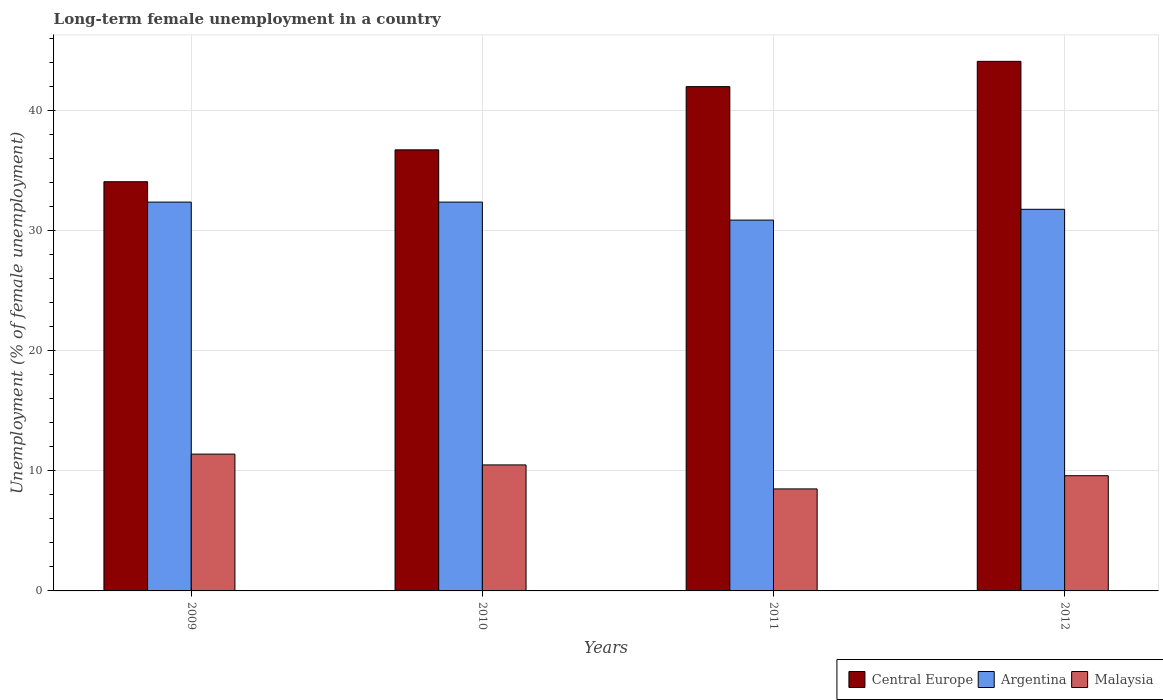How many different coloured bars are there?
Your answer should be compact. 3. How many bars are there on the 1st tick from the right?
Ensure brevity in your answer.  3. What is the label of the 4th group of bars from the left?
Give a very brief answer. 2012. In how many cases, is the number of bars for a given year not equal to the number of legend labels?
Provide a succinct answer. 0. What is the percentage of long-term unemployed female population in Central Europe in 2012?
Your answer should be very brief. 44.13. Across all years, what is the maximum percentage of long-term unemployed female population in Central Europe?
Your answer should be very brief. 44.13. Across all years, what is the minimum percentage of long-term unemployed female population in Central Europe?
Ensure brevity in your answer.  34.1. In which year was the percentage of long-term unemployed female population in Central Europe maximum?
Provide a succinct answer. 2012. What is the total percentage of long-term unemployed female population in Malaysia in the graph?
Make the answer very short. 40. What is the difference between the percentage of long-term unemployed female population in Argentina in 2010 and that in 2012?
Provide a short and direct response. 0.6. What is the difference between the percentage of long-term unemployed female population in Central Europe in 2011 and the percentage of long-term unemployed female population in Malaysia in 2009?
Provide a succinct answer. 30.62. What is the average percentage of long-term unemployed female population in Central Europe per year?
Your answer should be compact. 39.25. In the year 2009, what is the difference between the percentage of long-term unemployed female population in Central Europe and percentage of long-term unemployed female population in Argentina?
Your response must be concise. 1.7. What is the ratio of the percentage of long-term unemployed female population in Argentina in 2011 to that in 2012?
Your response must be concise. 0.97. What is the difference between the highest and the second highest percentage of long-term unemployed female population in Malaysia?
Ensure brevity in your answer.  0.9. What is the difference between the highest and the lowest percentage of long-term unemployed female population in Central Europe?
Provide a succinct answer. 10.03. Is the sum of the percentage of long-term unemployed female population in Argentina in 2009 and 2010 greater than the maximum percentage of long-term unemployed female population in Central Europe across all years?
Make the answer very short. Yes. What does the 3rd bar from the left in 2012 represents?
Offer a very short reply. Malaysia. What does the 3rd bar from the right in 2011 represents?
Offer a very short reply. Central Europe. Are all the bars in the graph horizontal?
Give a very brief answer. No. Does the graph contain any zero values?
Your response must be concise. No. Does the graph contain grids?
Keep it short and to the point. Yes. How are the legend labels stacked?
Keep it short and to the point. Horizontal. What is the title of the graph?
Provide a short and direct response. Long-term female unemployment in a country. What is the label or title of the Y-axis?
Keep it short and to the point. Unemployment (% of female unemployment). What is the Unemployment (% of female unemployment) in Central Europe in 2009?
Keep it short and to the point. 34.1. What is the Unemployment (% of female unemployment) in Argentina in 2009?
Your response must be concise. 32.4. What is the Unemployment (% of female unemployment) of Malaysia in 2009?
Provide a succinct answer. 11.4. What is the Unemployment (% of female unemployment) of Central Europe in 2010?
Your response must be concise. 36.75. What is the Unemployment (% of female unemployment) of Argentina in 2010?
Give a very brief answer. 32.4. What is the Unemployment (% of female unemployment) in Central Europe in 2011?
Your answer should be compact. 42.02. What is the Unemployment (% of female unemployment) of Argentina in 2011?
Ensure brevity in your answer.  30.9. What is the Unemployment (% of female unemployment) of Malaysia in 2011?
Make the answer very short. 8.5. What is the Unemployment (% of female unemployment) in Central Europe in 2012?
Ensure brevity in your answer.  44.13. What is the Unemployment (% of female unemployment) of Argentina in 2012?
Your answer should be very brief. 31.8. What is the Unemployment (% of female unemployment) in Malaysia in 2012?
Give a very brief answer. 9.6. Across all years, what is the maximum Unemployment (% of female unemployment) of Central Europe?
Keep it short and to the point. 44.13. Across all years, what is the maximum Unemployment (% of female unemployment) in Argentina?
Your response must be concise. 32.4. Across all years, what is the maximum Unemployment (% of female unemployment) in Malaysia?
Offer a very short reply. 11.4. Across all years, what is the minimum Unemployment (% of female unemployment) of Central Europe?
Ensure brevity in your answer.  34.1. Across all years, what is the minimum Unemployment (% of female unemployment) of Argentina?
Provide a succinct answer. 30.9. Across all years, what is the minimum Unemployment (% of female unemployment) of Malaysia?
Offer a very short reply. 8.5. What is the total Unemployment (% of female unemployment) in Central Europe in the graph?
Make the answer very short. 157. What is the total Unemployment (% of female unemployment) in Argentina in the graph?
Your response must be concise. 127.5. What is the difference between the Unemployment (% of female unemployment) of Central Europe in 2009 and that in 2010?
Ensure brevity in your answer.  -2.66. What is the difference between the Unemployment (% of female unemployment) in Argentina in 2009 and that in 2010?
Provide a short and direct response. 0. What is the difference between the Unemployment (% of female unemployment) of Central Europe in 2009 and that in 2011?
Provide a succinct answer. -7.93. What is the difference between the Unemployment (% of female unemployment) of Argentina in 2009 and that in 2011?
Keep it short and to the point. 1.5. What is the difference between the Unemployment (% of female unemployment) of Central Europe in 2009 and that in 2012?
Ensure brevity in your answer.  -10.03. What is the difference between the Unemployment (% of female unemployment) of Central Europe in 2010 and that in 2011?
Offer a very short reply. -5.27. What is the difference between the Unemployment (% of female unemployment) in Argentina in 2010 and that in 2011?
Your response must be concise. 1.5. What is the difference between the Unemployment (% of female unemployment) in Central Europe in 2010 and that in 2012?
Ensure brevity in your answer.  -7.37. What is the difference between the Unemployment (% of female unemployment) in Argentina in 2010 and that in 2012?
Give a very brief answer. 0.6. What is the difference between the Unemployment (% of female unemployment) in Malaysia in 2010 and that in 2012?
Keep it short and to the point. 0.9. What is the difference between the Unemployment (% of female unemployment) in Central Europe in 2011 and that in 2012?
Ensure brevity in your answer.  -2.1. What is the difference between the Unemployment (% of female unemployment) of Malaysia in 2011 and that in 2012?
Ensure brevity in your answer.  -1.1. What is the difference between the Unemployment (% of female unemployment) in Central Europe in 2009 and the Unemployment (% of female unemployment) in Argentina in 2010?
Ensure brevity in your answer.  1.7. What is the difference between the Unemployment (% of female unemployment) in Central Europe in 2009 and the Unemployment (% of female unemployment) in Malaysia in 2010?
Keep it short and to the point. 23.6. What is the difference between the Unemployment (% of female unemployment) of Argentina in 2009 and the Unemployment (% of female unemployment) of Malaysia in 2010?
Keep it short and to the point. 21.9. What is the difference between the Unemployment (% of female unemployment) in Central Europe in 2009 and the Unemployment (% of female unemployment) in Argentina in 2011?
Offer a terse response. 3.2. What is the difference between the Unemployment (% of female unemployment) in Central Europe in 2009 and the Unemployment (% of female unemployment) in Malaysia in 2011?
Your answer should be very brief. 25.6. What is the difference between the Unemployment (% of female unemployment) in Argentina in 2009 and the Unemployment (% of female unemployment) in Malaysia in 2011?
Make the answer very short. 23.9. What is the difference between the Unemployment (% of female unemployment) of Central Europe in 2009 and the Unemployment (% of female unemployment) of Argentina in 2012?
Provide a succinct answer. 2.3. What is the difference between the Unemployment (% of female unemployment) of Central Europe in 2009 and the Unemployment (% of female unemployment) of Malaysia in 2012?
Your answer should be very brief. 24.5. What is the difference between the Unemployment (% of female unemployment) in Argentina in 2009 and the Unemployment (% of female unemployment) in Malaysia in 2012?
Offer a terse response. 22.8. What is the difference between the Unemployment (% of female unemployment) of Central Europe in 2010 and the Unemployment (% of female unemployment) of Argentina in 2011?
Provide a short and direct response. 5.85. What is the difference between the Unemployment (% of female unemployment) of Central Europe in 2010 and the Unemployment (% of female unemployment) of Malaysia in 2011?
Your answer should be compact. 28.25. What is the difference between the Unemployment (% of female unemployment) in Argentina in 2010 and the Unemployment (% of female unemployment) in Malaysia in 2011?
Your answer should be very brief. 23.9. What is the difference between the Unemployment (% of female unemployment) in Central Europe in 2010 and the Unemployment (% of female unemployment) in Argentina in 2012?
Offer a very short reply. 4.95. What is the difference between the Unemployment (% of female unemployment) in Central Europe in 2010 and the Unemployment (% of female unemployment) in Malaysia in 2012?
Your response must be concise. 27.15. What is the difference between the Unemployment (% of female unemployment) in Argentina in 2010 and the Unemployment (% of female unemployment) in Malaysia in 2012?
Provide a succinct answer. 22.8. What is the difference between the Unemployment (% of female unemployment) of Central Europe in 2011 and the Unemployment (% of female unemployment) of Argentina in 2012?
Give a very brief answer. 10.22. What is the difference between the Unemployment (% of female unemployment) of Central Europe in 2011 and the Unemployment (% of female unemployment) of Malaysia in 2012?
Your response must be concise. 32.42. What is the difference between the Unemployment (% of female unemployment) of Argentina in 2011 and the Unemployment (% of female unemployment) of Malaysia in 2012?
Offer a terse response. 21.3. What is the average Unemployment (% of female unemployment) of Central Europe per year?
Your response must be concise. 39.25. What is the average Unemployment (% of female unemployment) in Argentina per year?
Give a very brief answer. 31.88. What is the average Unemployment (% of female unemployment) of Malaysia per year?
Provide a short and direct response. 10. In the year 2009, what is the difference between the Unemployment (% of female unemployment) in Central Europe and Unemployment (% of female unemployment) in Argentina?
Your answer should be compact. 1.7. In the year 2009, what is the difference between the Unemployment (% of female unemployment) of Central Europe and Unemployment (% of female unemployment) of Malaysia?
Offer a terse response. 22.7. In the year 2010, what is the difference between the Unemployment (% of female unemployment) in Central Europe and Unemployment (% of female unemployment) in Argentina?
Keep it short and to the point. 4.35. In the year 2010, what is the difference between the Unemployment (% of female unemployment) in Central Europe and Unemployment (% of female unemployment) in Malaysia?
Provide a short and direct response. 26.25. In the year 2010, what is the difference between the Unemployment (% of female unemployment) of Argentina and Unemployment (% of female unemployment) of Malaysia?
Offer a terse response. 21.9. In the year 2011, what is the difference between the Unemployment (% of female unemployment) in Central Europe and Unemployment (% of female unemployment) in Argentina?
Provide a succinct answer. 11.12. In the year 2011, what is the difference between the Unemployment (% of female unemployment) of Central Europe and Unemployment (% of female unemployment) of Malaysia?
Your response must be concise. 33.52. In the year 2011, what is the difference between the Unemployment (% of female unemployment) in Argentina and Unemployment (% of female unemployment) in Malaysia?
Give a very brief answer. 22.4. In the year 2012, what is the difference between the Unemployment (% of female unemployment) in Central Europe and Unemployment (% of female unemployment) in Argentina?
Ensure brevity in your answer.  12.33. In the year 2012, what is the difference between the Unemployment (% of female unemployment) of Central Europe and Unemployment (% of female unemployment) of Malaysia?
Offer a terse response. 34.53. In the year 2012, what is the difference between the Unemployment (% of female unemployment) of Argentina and Unemployment (% of female unemployment) of Malaysia?
Provide a short and direct response. 22.2. What is the ratio of the Unemployment (% of female unemployment) of Central Europe in 2009 to that in 2010?
Your response must be concise. 0.93. What is the ratio of the Unemployment (% of female unemployment) of Argentina in 2009 to that in 2010?
Your response must be concise. 1. What is the ratio of the Unemployment (% of female unemployment) of Malaysia in 2009 to that in 2010?
Keep it short and to the point. 1.09. What is the ratio of the Unemployment (% of female unemployment) of Central Europe in 2009 to that in 2011?
Your response must be concise. 0.81. What is the ratio of the Unemployment (% of female unemployment) in Argentina in 2009 to that in 2011?
Give a very brief answer. 1.05. What is the ratio of the Unemployment (% of female unemployment) of Malaysia in 2009 to that in 2011?
Provide a short and direct response. 1.34. What is the ratio of the Unemployment (% of female unemployment) of Central Europe in 2009 to that in 2012?
Provide a succinct answer. 0.77. What is the ratio of the Unemployment (% of female unemployment) of Argentina in 2009 to that in 2012?
Provide a short and direct response. 1.02. What is the ratio of the Unemployment (% of female unemployment) of Malaysia in 2009 to that in 2012?
Offer a terse response. 1.19. What is the ratio of the Unemployment (% of female unemployment) in Central Europe in 2010 to that in 2011?
Make the answer very short. 0.87. What is the ratio of the Unemployment (% of female unemployment) of Argentina in 2010 to that in 2011?
Give a very brief answer. 1.05. What is the ratio of the Unemployment (% of female unemployment) of Malaysia in 2010 to that in 2011?
Provide a succinct answer. 1.24. What is the ratio of the Unemployment (% of female unemployment) in Central Europe in 2010 to that in 2012?
Offer a very short reply. 0.83. What is the ratio of the Unemployment (% of female unemployment) in Argentina in 2010 to that in 2012?
Your answer should be very brief. 1.02. What is the ratio of the Unemployment (% of female unemployment) in Malaysia in 2010 to that in 2012?
Ensure brevity in your answer.  1.09. What is the ratio of the Unemployment (% of female unemployment) in Central Europe in 2011 to that in 2012?
Offer a terse response. 0.95. What is the ratio of the Unemployment (% of female unemployment) of Argentina in 2011 to that in 2012?
Offer a very short reply. 0.97. What is the ratio of the Unemployment (% of female unemployment) in Malaysia in 2011 to that in 2012?
Offer a terse response. 0.89. What is the difference between the highest and the second highest Unemployment (% of female unemployment) in Central Europe?
Give a very brief answer. 2.1. What is the difference between the highest and the second highest Unemployment (% of female unemployment) of Argentina?
Make the answer very short. 0. What is the difference between the highest and the second highest Unemployment (% of female unemployment) in Malaysia?
Provide a succinct answer. 0.9. What is the difference between the highest and the lowest Unemployment (% of female unemployment) in Central Europe?
Your answer should be compact. 10.03. 